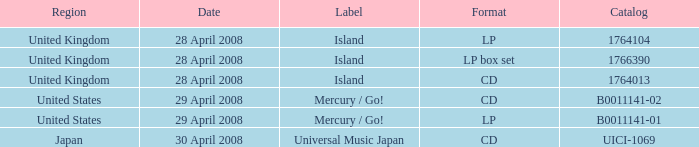What is the Region of the 1766390 Catalog? United Kingdom. 